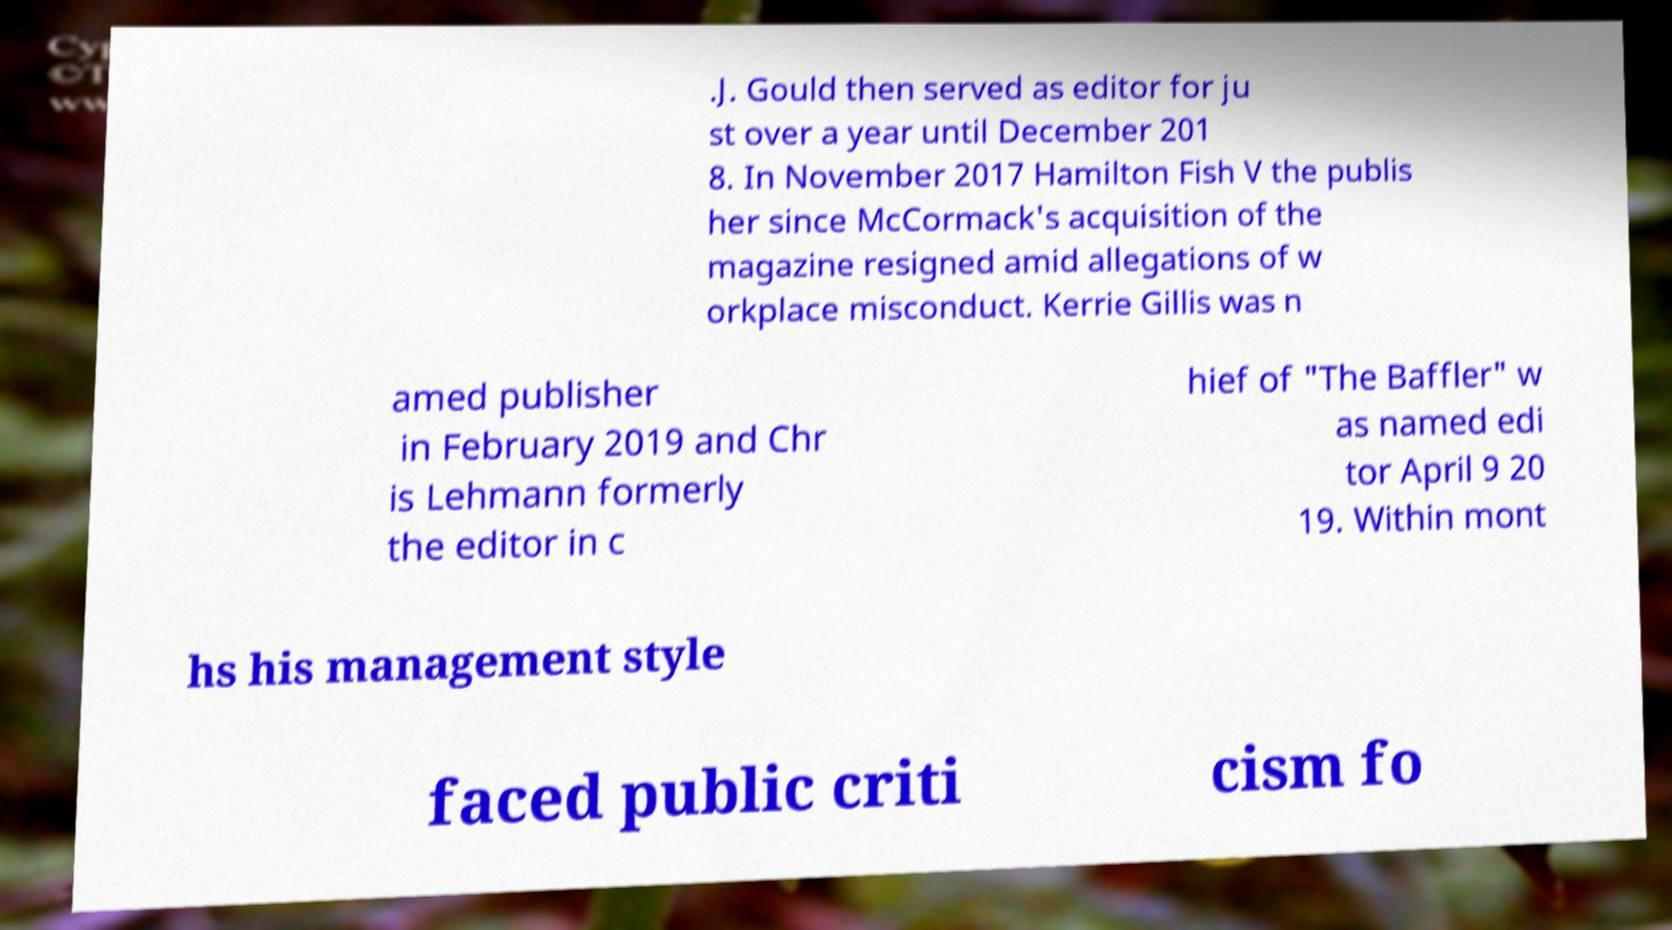For documentation purposes, I need the text within this image transcribed. Could you provide that? .J. Gould then served as editor for ju st over a year until December 201 8. In November 2017 Hamilton Fish V the publis her since McCormack's acquisition of the magazine resigned amid allegations of w orkplace misconduct. Kerrie Gillis was n amed publisher in February 2019 and Chr is Lehmann formerly the editor in c hief of "The Baffler" w as named edi tor April 9 20 19. Within mont hs his management style faced public criti cism fo 